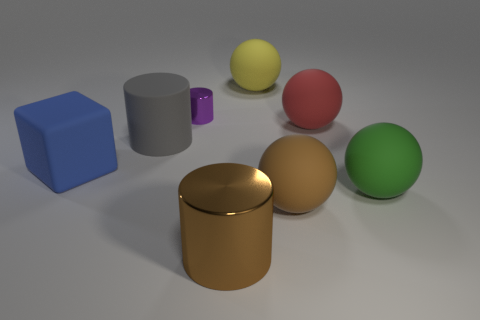Subtract all brown balls. How many balls are left? 3 Add 1 purple objects. How many objects exist? 9 Subtract all purple cylinders. How many cylinders are left? 2 Subtract all blocks. How many objects are left? 7 Subtract all red spheres. Subtract all cyan cylinders. How many spheres are left? 3 Subtract all green cubes. How many purple cylinders are left? 1 Subtract all big brown rubber objects. Subtract all matte cylinders. How many objects are left? 6 Add 7 big metallic cylinders. How many big metallic cylinders are left? 8 Add 3 big matte blocks. How many big matte blocks exist? 4 Subtract 0 brown cubes. How many objects are left? 8 